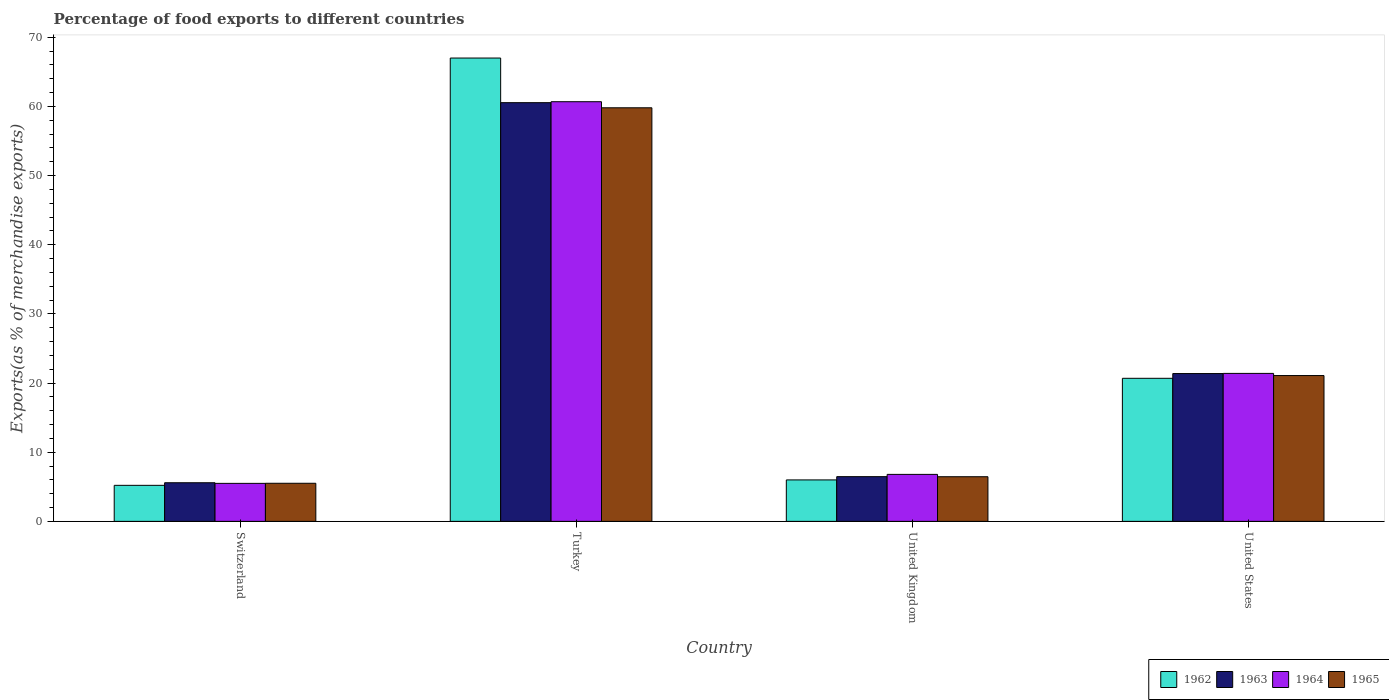How many bars are there on the 2nd tick from the left?
Your answer should be compact. 4. What is the percentage of exports to different countries in 1964 in Switzerland?
Give a very brief answer. 5.49. Across all countries, what is the maximum percentage of exports to different countries in 1965?
Provide a succinct answer. 59.8. Across all countries, what is the minimum percentage of exports to different countries in 1965?
Give a very brief answer. 5.51. In which country was the percentage of exports to different countries in 1964 maximum?
Offer a very short reply. Turkey. In which country was the percentage of exports to different countries in 1962 minimum?
Ensure brevity in your answer.  Switzerland. What is the total percentage of exports to different countries in 1964 in the graph?
Offer a very short reply. 94.36. What is the difference between the percentage of exports to different countries in 1962 in Switzerland and that in United Kingdom?
Your answer should be compact. -0.78. What is the difference between the percentage of exports to different countries in 1965 in Switzerland and the percentage of exports to different countries in 1964 in Turkey?
Your answer should be compact. -55.17. What is the average percentage of exports to different countries in 1964 per country?
Ensure brevity in your answer.  23.59. What is the difference between the percentage of exports to different countries of/in 1962 and percentage of exports to different countries of/in 1964 in Turkey?
Your answer should be compact. 6.31. What is the ratio of the percentage of exports to different countries in 1962 in United Kingdom to that in United States?
Your response must be concise. 0.29. What is the difference between the highest and the second highest percentage of exports to different countries in 1965?
Offer a very short reply. 38.72. What is the difference between the highest and the lowest percentage of exports to different countries in 1964?
Your response must be concise. 55.18. Is the sum of the percentage of exports to different countries in 1964 in Switzerland and United Kingdom greater than the maximum percentage of exports to different countries in 1965 across all countries?
Provide a short and direct response. No. Is it the case that in every country, the sum of the percentage of exports to different countries in 1963 and percentage of exports to different countries in 1964 is greater than the sum of percentage of exports to different countries in 1962 and percentage of exports to different countries in 1965?
Your answer should be very brief. No. What does the 1st bar from the left in United Kingdom represents?
Provide a succinct answer. 1962. What does the 1st bar from the right in Switzerland represents?
Provide a succinct answer. 1965. Is it the case that in every country, the sum of the percentage of exports to different countries in 1964 and percentage of exports to different countries in 1965 is greater than the percentage of exports to different countries in 1962?
Your response must be concise. Yes. How many countries are there in the graph?
Ensure brevity in your answer.  4. Does the graph contain any zero values?
Offer a terse response. No. Does the graph contain grids?
Your answer should be compact. No. How many legend labels are there?
Provide a succinct answer. 4. How are the legend labels stacked?
Provide a short and direct response. Horizontal. What is the title of the graph?
Your answer should be very brief. Percentage of food exports to different countries. What is the label or title of the X-axis?
Give a very brief answer. Country. What is the label or title of the Y-axis?
Your response must be concise. Exports(as % of merchandise exports). What is the Exports(as % of merchandise exports) in 1962 in Switzerland?
Keep it short and to the point. 5.21. What is the Exports(as % of merchandise exports) in 1963 in Switzerland?
Offer a terse response. 5.59. What is the Exports(as % of merchandise exports) in 1964 in Switzerland?
Your answer should be compact. 5.49. What is the Exports(as % of merchandise exports) in 1965 in Switzerland?
Provide a short and direct response. 5.51. What is the Exports(as % of merchandise exports) of 1962 in Turkey?
Your response must be concise. 66.99. What is the Exports(as % of merchandise exports) in 1963 in Turkey?
Your answer should be very brief. 60.54. What is the Exports(as % of merchandise exports) of 1964 in Turkey?
Offer a terse response. 60.68. What is the Exports(as % of merchandise exports) of 1965 in Turkey?
Provide a succinct answer. 59.8. What is the Exports(as % of merchandise exports) of 1962 in United Kingdom?
Ensure brevity in your answer.  5.99. What is the Exports(as % of merchandise exports) of 1963 in United Kingdom?
Keep it short and to the point. 6.47. What is the Exports(as % of merchandise exports) of 1964 in United Kingdom?
Ensure brevity in your answer.  6.79. What is the Exports(as % of merchandise exports) in 1965 in United Kingdom?
Ensure brevity in your answer.  6.45. What is the Exports(as % of merchandise exports) of 1962 in United States?
Give a very brief answer. 20.68. What is the Exports(as % of merchandise exports) in 1963 in United States?
Your answer should be very brief. 21.37. What is the Exports(as % of merchandise exports) in 1964 in United States?
Provide a succinct answer. 21.39. What is the Exports(as % of merchandise exports) of 1965 in United States?
Your answer should be very brief. 21.08. Across all countries, what is the maximum Exports(as % of merchandise exports) in 1962?
Your answer should be compact. 66.99. Across all countries, what is the maximum Exports(as % of merchandise exports) in 1963?
Offer a very short reply. 60.54. Across all countries, what is the maximum Exports(as % of merchandise exports) of 1964?
Give a very brief answer. 60.68. Across all countries, what is the maximum Exports(as % of merchandise exports) in 1965?
Provide a succinct answer. 59.8. Across all countries, what is the minimum Exports(as % of merchandise exports) in 1962?
Ensure brevity in your answer.  5.21. Across all countries, what is the minimum Exports(as % of merchandise exports) in 1963?
Ensure brevity in your answer.  5.59. Across all countries, what is the minimum Exports(as % of merchandise exports) in 1964?
Your answer should be very brief. 5.49. Across all countries, what is the minimum Exports(as % of merchandise exports) in 1965?
Offer a terse response. 5.51. What is the total Exports(as % of merchandise exports) of 1962 in the graph?
Your answer should be compact. 98.88. What is the total Exports(as % of merchandise exports) in 1963 in the graph?
Your response must be concise. 93.96. What is the total Exports(as % of merchandise exports) of 1964 in the graph?
Offer a terse response. 94.36. What is the total Exports(as % of merchandise exports) in 1965 in the graph?
Provide a short and direct response. 92.84. What is the difference between the Exports(as % of merchandise exports) in 1962 in Switzerland and that in Turkey?
Offer a terse response. -61.78. What is the difference between the Exports(as % of merchandise exports) of 1963 in Switzerland and that in Turkey?
Make the answer very short. -54.96. What is the difference between the Exports(as % of merchandise exports) of 1964 in Switzerland and that in Turkey?
Your answer should be very brief. -55.18. What is the difference between the Exports(as % of merchandise exports) in 1965 in Switzerland and that in Turkey?
Give a very brief answer. -54.29. What is the difference between the Exports(as % of merchandise exports) of 1962 in Switzerland and that in United Kingdom?
Give a very brief answer. -0.78. What is the difference between the Exports(as % of merchandise exports) in 1963 in Switzerland and that in United Kingdom?
Your answer should be very brief. -0.88. What is the difference between the Exports(as % of merchandise exports) of 1965 in Switzerland and that in United Kingdom?
Ensure brevity in your answer.  -0.95. What is the difference between the Exports(as % of merchandise exports) in 1962 in Switzerland and that in United States?
Provide a short and direct response. -15.48. What is the difference between the Exports(as % of merchandise exports) of 1963 in Switzerland and that in United States?
Your answer should be very brief. -15.79. What is the difference between the Exports(as % of merchandise exports) in 1964 in Switzerland and that in United States?
Give a very brief answer. -15.9. What is the difference between the Exports(as % of merchandise exports) in 1965 in Switzerland and that in United States?
Make the answer very short. -15.58. What is the difference between the Exports(as % of merchandise exports) of 1962 in Turkey and that in United Kingdom?
Provide a short and direct response. 61. What is the difference between the Exports(as % of merchandise exports) in 1963 in Turkey and that in United Kingdom?
Ensure brevity in your answer.  54.08. What is the difference between the Exports(as % of merchandise exports) of 1964 in Turkey and that in United Kingdom?
Your response must be concise. 53.88. What is the difference between the Exports(as % of merchandise exports) in 1965 in Turkey and that in United Kingdom?
Your answer should be very brief. 53.34. What is the difference between the Exports(as % of merchandise exports) of 1962 in Turkey and that in United States?
Make the answer very short. 46.31. What is the difference between the Exports(as % of merchandise exports) in 1963 in Turkey and that in United States?
Ensure brevity in your answer.  39.17. What is the difference between the Exports(as % of merchandise exports) in 1964 in Turkey and that in United States?
Provide a succinct answer. 39.28. What is the difference between the Exports(as % of merchandise exports) in 1965 in Turkey and that in United States?
Give a very brief answer. 38.72. What is the difference between the Exports(as % of merchandise exports) of 1962 in United Kingdom and that in United States?
Keep it short and to the point. -14.69. What is the difference between the Exports(as % of merchandise exports) of 1963 in United Kingdom and that in United States?
Offer a very short reply. -14.91. What is the difference between the Exports(as % of merchandise exports) in 1964 in United Kingdom and that in United States?
Make the answer very short. -14.6. What is the difference between the Exports(as % of merchandise exports) in 1965 in United Kingdom and that in United States?
Your response must be concise. -14.63. What is the difference between the Exports(as % of merchandise exports) of 1962 in Switzerland and the Exports(as % of merchandise exports) of 1963 in Turkey?
Provide a succinct answer. -55.33. What is the difference between the Exports(as % of merchandise exports) of 1962 in Switzerland and the Exports(as % of merchandise exports) of 1964 in Turkey?
Offer a terse response. -55.47. What is the difference between the Exports(as % of merchandise exports) of 1962 in Switzerland and the Exports(as % of merchandise exports) of 1965 in Turkey?
Offer a very short reply. -54.59. What is the difference between the Exports(as % of merchandise exports) in 1963 in Switzerland and the Exports(as % of merchandise exports) in 1964 in Turkey?
Your response must be concise. -55.09. What is the difference between the Exports(as % of merchandise exports) of 1963 in Switzerland and the Exports(as % of merchandise exports) of 1965 in Turkey?
Ensure brevity in your answer.  -54.21. What is the difference between the Exports(as % of merchandise exports) of 1964 in Switzerland and the Exports(as % of merchandise exports) of 1965 in Turkey?
Your answer should be very brief. -54.31. What is the difference between the Exports(as % of merchandise exports) in 1962 in Switzerland and the Exports(as % of merchandise exports) in 1963 in United Kingdom?
Make the answer very short. -1.26. What is the difference between the Exports(as % of merchandise exports) in 1962 in Switzerland and the Exports(as % of merchandise exports) in 1964 in United Kingdom?
Provide a succinct answer. -1.58. What is the difference between the Exports(as % of merchandise exports) of 1962 in Switzerland and the Exports(as % of merchandise exports) of 1965 in United Kingdom?
Give a very brief answer. -1.25. What is the difference between the Exports(as % of merchandise exports) in 1963 in Switzerland and the Exports(as % of merchandise exports) in 1964 in United Kingdom?
Keep it short and to the point. -1.21. What is the difference between the Exports(as % of merchandise exports) of 1963 in Switzerland and the Exports(as % of merchandise exports) of 1965 in United Kingdom?
Make the answer very short. -0.87. What is the difference between the Exports(as % of merchandise exports) of 1964 in Switzerland and the Exports(as % of merchandise exports) of 1965 in United Kingdom?
Offer a very short reply. -0.96. What is the difference between the Exports(as % of merchandise exports) in 1962 in Switzerland and the Exports(as % of merchandise exports) in 1963 in United States?
Offer a terse response. -16.16. What is the difference between the Exports(as % of merchandise exports) in 1962 in Switzerland and the Exports(as % of merchandise exports) in 1964 in United States?
Offer a terse response. -16.18. What is the difference between the Exports(as % of merchandise exports) in 1962 in Switzerland and the Exports(as % of merchandise exports) in 1965 in United States?
Make the answer very short. -15.87. What is the difference between the Exports(as % of merchandise exports) of 1963 in Switzerland and the Exports(as % of merchandise exports) of 1964 in United States?
Provide a succinct answer. -15.81. What is the difference between the Exports(as % of merchandise exports) of 1963 in Switzerland and the Exports(as % of merchandise exports) of 1965 in United States?
Give a very brief answer. -15.5. What is the difference between the Exports(as % of merchandise exports) of 1964 in Switzerland and the Exports(as % of merchandise exports) of 1965 in United States?
Give a very brief answer. -15.59. What is the difference between the Exports(as % of merchandise exports) in 1962 in Turkey and the Exports(as % of merchandise exports) in 1963 in United Kingdom?
Offer a terse response. 60.53. What is the difference between the Exports(as % of merchandise exports) in 1962 in Turkey and the Exports(as % of merchandise exports) in 1964 in United Kingdom?
Offer a very short reply. 60.2. What is the difference between the Exports(as % of merchandise exports) of 1962 in Turkey and the Exports(as % of merchandise exports) of 1965 in United Kingdom?
Give a very brief answer. 60.54. What is the difference between the Exports(as % of merchandise exports) of 1963 in Turkey and the Exports(as % of merchandise exports) of 1964 in United Kingdom?
Offer a terse response. 53.75. What is the difference between the Exports(as % of merchandise exports) in 1963 in Turkey and the Exports(as % of merchandise exports) in 1965 in United Kingdom?
Your answer should be compact. 54.09. What is the difference between the Exports(as % of merchandise exports) in 1964 in Turkey and the Exports(as % of merchandise exports) in 1965 in United Kingdom?
Offer a very short reply. 54.22. What is the difference between the Exports(as % of merchandise exports) of 1962 in Turkey and the Exports(as % of merchandise exports) of 1963 in United States?
Provide a short and direct response. 45.62. What is the difference between the Exports(as % of merchandise exports) of 1962 in Turkey and the Exports(as % of merchandise exports) of 1964 in United States?
Your answer should be very brief. 45.6. What is the difference between the Exports(as % of merchandise exports) of 1962 in Turkey and the Exports(as % of merchandise exports) of 1965 in United States?
Your response must be concise. 45.91. What is the difference between the Exports(as % of merchandise exports) of 1963 in Turkey and the Exports(as % of merchandise exports) of 1964 in United States?
Your answer should be very brief. 39.15. What is the difference between the Exports(as % of merchandise exports) of 1963 in Turkey and the Exports(as % of merchandise exports) of 1965 in United States?
Provide a short and direct response. 39.46. What is the difference between the Exports(as % of merchandise exports) of 1964 in Turkey and the Exports(as % of merchandise exports) of 1965 in United States?
Ensure brevity in your answer.  39.59. What is the difference between the Exports(as % of merchandise exports) of 1962 in United Kingdom and the Exports(as % of merchandise exports) of 1963 in United States?
Keep it short and to the point. -15.38. What is the difference between the Exports(as % of merchandise exports) of 1962 in United Kingdom and the Exports(as % of merchandise exports) of 1964 in United States?
Offer a very short reply. -15.4. What is the difference between the Exports(as % of merchandise exports) of 1962 in United Kingdom and the Exports(as % of merchandise exports) of 1965 in United States?
Your answer should be compact. -15.09. What is the difference between the Exports(as % of merchandise exports) of 1963 in United Kingdom and the Exports(as % of merchandise exports) of 1964 in United States?
Your answer should be compact. -14.93. What is the difference between the Exports(as % of merchandise exports) of 1963 in United Kingdom and the Exports(as % of merchandise exports) of 1965 in United States?
Make the answer very short. -14.62. What is the difference between the Exports(as % of merchandise exports) in 1964 in United Kingdom and the Exports(as % of merchandise exports) in 1965 in United States?
Your answer should be very brief. -14.29. What is the average Exports(as % of merchandise exports) in 1962 per country?
Keep it short and to the point. 24.72. What is the average Exports(as % of merchandise exports) of 1963 per country?
Provide a succinct answer. 23.49. What is the average Exports(as % of merchandise exports) of 1964 per country?
Provide a short and direct response. 23.59. What is the average Exports(as % of merchandise exports) of 1965 per country?
Keep it short and to the point. 23.21. What is the difference between the Exports(as % of merchandise exports) of 1962 and Exports(as % of merchandise exports) of 1963 in Switzerland?
Offer a terse response. -0.38. What is the difference between the Exports(as % of merchandise exports) in 1962 and Exports(as % of merchandise exports) in 1964 in Switzerland?
Ensure brevity in your answer.  -0.28. What is the difference between the Exports(as % of merchandise exports) of 1962 and Exports(as % of merchandise exports) of 1965 in Switzerland?
Give a very brief answer. -0.3. What is the difference between the Exports(as % of merchandise exports) of 1963 and Exports(as % of merchandise exports) of 1964 in Switzerland?
Your answer should be compact. 0.09. What is the difference between the Exports(as % of merchandise exports) in 1963 and Exports(as % of merchandise exports) in 1965 in Switzerland?
Offer a very short reply. 0.08. What is the difference between the Exports(as % of merchandise exports) of 1964 and Exports(as % of merchandise exports) of 1965 in Switzerland?
Your response must be concise. -0.01. What is the difference between the Exports(as % of merchandise exports) of 1962 and Exports(as % of merchandise exports) of 1963 in Turkey?
Make the answer very short. 6.45. What is the difference between the Exports(as % of merchandise exports) of 1962 and Exports(as % of merchandise exports) of 1964 in Turkey?
Offer a terse response. 6.31. What is the difference between the Exports(as % of merchandise exports) in 1962 and Exports(as % of merchandise exports) in 1965 in Turkey?
Your response must be concise. 7.19. What is the difference between the Exports(as % of merchandise exports) in 1963 and Exports(as % of merchandise exports) in 1964 in Turkey?
Your answer should be compact. -0.14. What is the difference between the Exports(as % of merchandise exports) of 1963 and Exports(as % of merchandise exports) of 1965 in Turkey?
Your answer should be compact. 0.74. What is the difference between the Exports(as % of merchandise exports) in 1964 and Exports(as % of merchandise exports) in 1965 in Turkey?
Your response must be concise. 0.88. What is the difference between the Exports(as % of merchandise exports) of 1962 and Exports(as % of merchandise exports) of 1963 in United Kingdom?
Offer a terse response. -0.47. What is the difference between the Exports(as % of merchandise exports) in 1962 and Exports(as % of merchandise exports) in 1964 in United Kingdom?
Make the answer very short. -0.8. What is the difference between the Exports(as % of merchandise exports) of 1962 and Exports(as % of merchandise exports) of 1965 in United Kingdom?
Make the answer very short. -0.46. What is the difference between the Exports(as % of merchandise exports) of 1963 and Exports(as % of merchandise exports) of 1964 in United Kingdom?
Keep it short and to the point. -0.33. What is the difference between the Exports(as % of merchandise exports) in 1963 and Exports(as % of merchandise exports) in 1965 in United Kingdom?
Give a very brief answer. 0.01. What is the difference between the Exports(as % of merchandise exports) in 1964 and Exports(as % of merchandise exports) in 1965 in United Kingdom?
Provide a succinct answer. 0.34. What is the difference between the Exports(as % of merchandise exports) in 1962 and Exports(as % of merchandise exports) in 1963 in United States?
Make the answer very short. -0.69. What is the difference between the Exports(as % of merchandise exports) of 1962 and Exports(as % of merchandise exports) of 1964 in United States?
Make the answer very short. -0.71. What is the difference between the Exports(as % of merchandise exports) in 1962 and Exports(as % of merchandise exports) in 1965 in United States?
Give a very brief answer. -0.4. What is the difference between the Exports(as % of merchandise exports) in 1963 and Exports(as % of merchandise exports) in 1964 in United States?
Offer a terse response. -0.02. What is the difference between the Exports(as % of merchandise exports) of 1963 and Exports(as % of merchandise exports) of 1965 in United States?
Give a very brief answer. 0.29. What is the difference between the Exports(as % of merchandise exports) in 1964 and Exports(as % of merchandise exports) in 1965 in United States?
Keep it short and to the point. 0.31. What is the ratio of the Exports(as % of merchandise exports) of 1962 in Switzerland to that in Turkey?
Give a very brief answer. 0.08. What is the ratio of the Exports(as % of merchandise exports) in 1963 in Switzerland to that in Turkey?
Your response must be concise. 0.09. What is the ratio of the Exports(as % of merchandise exports) in 1964 in Switzerland to that in Turkey?
Your response must be concise. 0.09. What is the ratio of the Exports(as % of merchandise exports) of 1965 in Switzerland to that in Turkey?
Provide a succinct answer. 0.09. What is the ratio of the Exports(as % of merchandise exports) in 1962 in Switzerland to that in United Kingdom?
Your response must be concise. 0.87. What is the ratio of the Exports(as % of merchandise exports) of 1963 in Switzerland to that in United Kingdom?
Ensure brevity in your answer.  0.86. What is the ratio of the Exports(as % of merchandise exports) of 1964 in Switzerland to that in United Kingdom?
Your answer should be very brief. 0.81. What is the ratio of the Exports(as % of merchandise exports) in 1965 in Switzerland to that in United Kingdom?
Ensure brevity in your answer.  0.85. What is the ratio of the Exports(as % of merchandise exports) of 1962 in Switzerland to that in United States?
Provide a short and direct response. 0.25. What is the ratio of the Exports(as % of merchandise exports) in 1963 in Switzerland to that in United States?
Offer a terse response. 0.26. What is the ratio of the Exports(as % of merchandise exports) in 1964 in Switzerland to that in United States?
Your answer should be very brief. 0.26. What is the ratio of the Exports(as % of merchandise exports) in 1965 in Switzerland to that in United States?
Give a very brief answer. 0.26. What is the ratio of the Exports(as % of merchandise exports) in 1962 in Turkey to that in United Kingdom?
Ensure brevity in your answer.  11.18. What is the ratio of the Exports(as % of merchandise exports) in 1963 in Turkey to that in United Kingdom?
Offer a very short reply. 9.36. What is the ratio of the Exports(as % of merchandise exports) of 1964 in Turkey to that in United Kingdom?
Provide a short and direct response. 8.93. What is the ratio of the Exports(as % of merchandise exports) of 1965 in Turkey to that in United Kingdom?
Ensure brevity in your answer.  9.26. What is the ratio of the Exports(as % of merchandise exports) of 1962 in Turkey to that in United States?
Your answer should be very brief. 3.24. What is the ratio of the Exports(as % of merchandise exports) of 1963 in Turkey to that in United States?
Offer a very short reply. 2.83. What is the ratio of the Exports(as % of merchandise exports) in 1964 in Turkey to that in United States?
Give a very brief answer. 2.84. What is the ratio of the Exports(as % of merchandise exports) in 1965 in Turkey to that in United States?
Offer a terse response. 2.84. What is the ratio of the Exports(as % of merchandise exports) in 1962 in United Kingdom to that in United States?
Your answer should be very brief. 0.29. What is the ratio of the Exports(as % of merchandise exports) in 1963 in United Kingdom to that in United States?
Provide a succinct answer. 0.3. What is the ratio of the Exports(as % of merchandise exports) in 1964 in United Kingdom to that in United States?
Offer a very short reply. 0.32. What is the ratio of the Exports(as % of merchandise exports) of 1965 in United Kingdom to that in United States?
Offer a very short reply. 0.31. What is the difference between the highest and the second highest Exports(as % of merchandise exports) of 1962?
Your response must be concise. 46.31. What is the difference between the highest and the second highest Exports(as % of merchandise exports) in 1963?
Ensure brevity in your answer.  39.17. What is the difference between the highest and the second highest Exports(as % of merchandise exports) in 1964?
Your answer should be very brief. 39.28. What is the difference between the highest and the second highest Exports(as % of merchandise exports) in 1965?
Give a very brief answer. 38.72. What is the difference between the highest and the lowest Exports(as % of merchandise exports) in 1962?
Provide a short and direct response. 61.78. What is the difference between the highest and the lowest Exports(as % of merchandise exports) of 1963?
Give a very brief answer. 54.96. What is the difference between the highest and the lowest Exports(as % of merchandise exports) in 1964?
Offer a very short reply. 55.18. What is the difference between the highest and the lowest Exports(as % of merchandise exports) in 1965?
Keep it short and to the point. 54.29. 